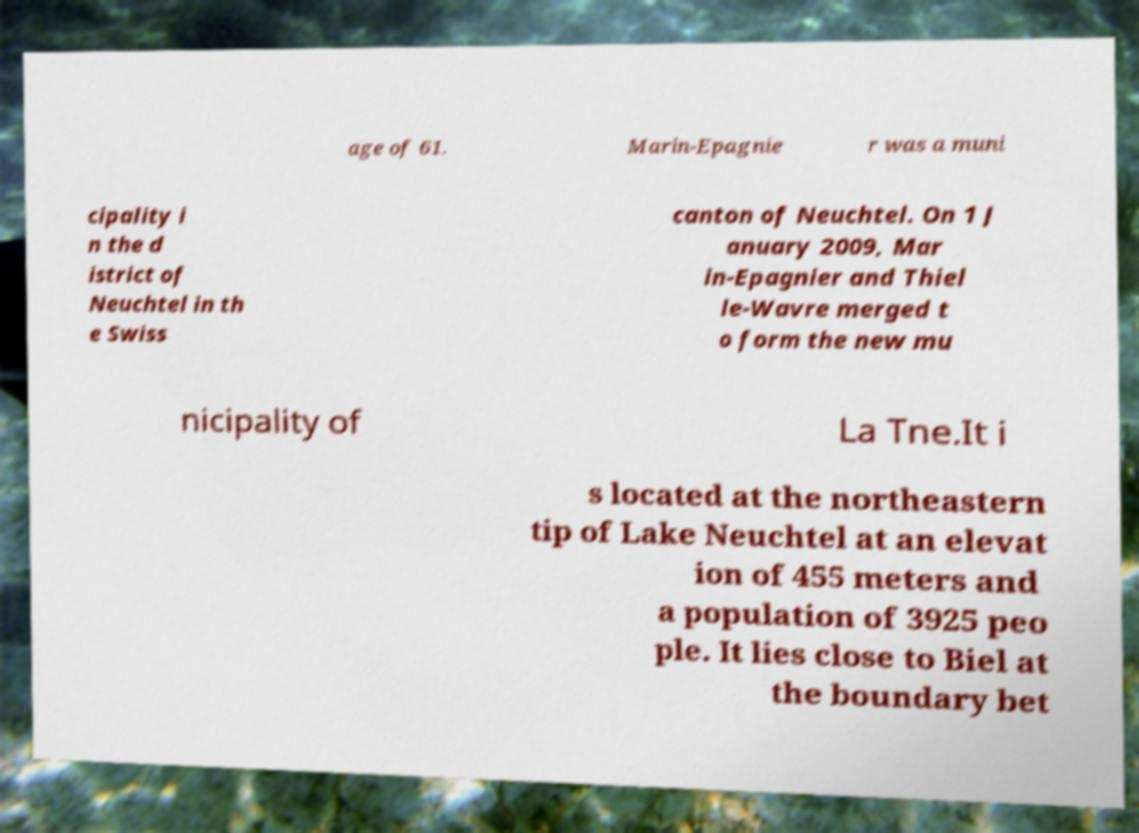I need the written content from this picture converted into text. Can you do that? age of 61. Marin-Epagnie r was a muni cipality i n the d istrict of Neuchtel in th e Swiss canton of Neuchtel. On 1 J anuary 2009, Mar in-Epagnier and Thiel le-Wavre merged t o form the new mu nicipality of La Tne.It i s located at the northeastern tip of Lake Neuchtel at an elevat ion of 455 meters and a population of 3925 peo ple. It lies close to Biel at the boundary bet 